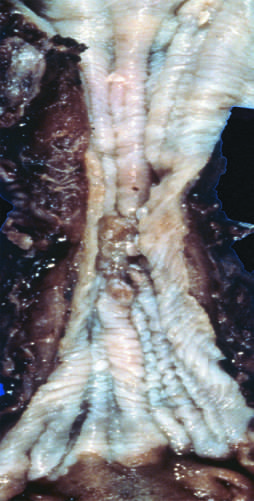s cd15 found in the mid-esophagus, where it commonly causes strictures?
Answer the question using a single word or phrase. No 